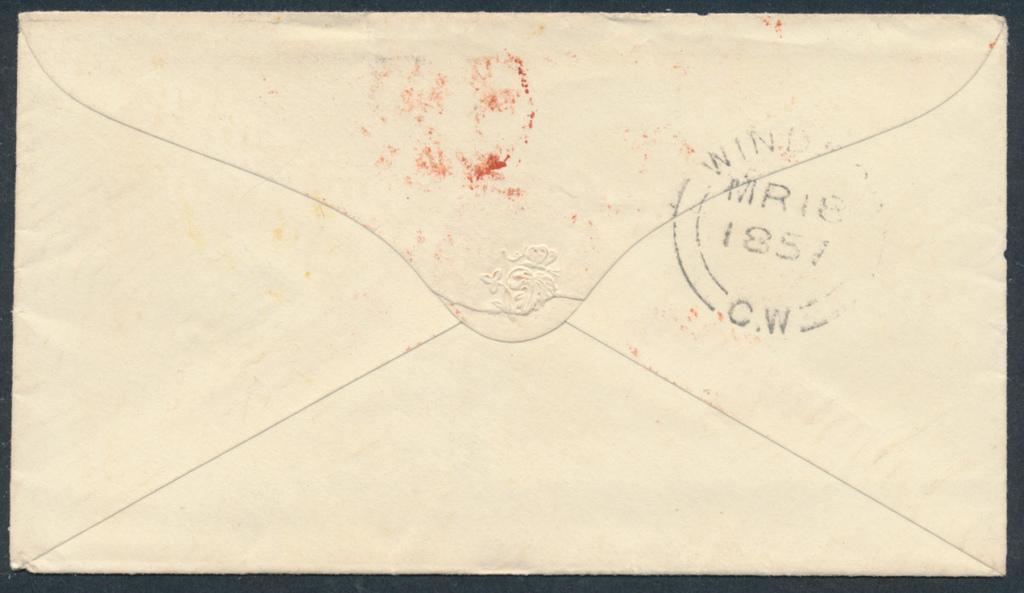<image>
Relay a brief, clear account of the picture shown. The back of a cream colored envelope has a stamp with the letters CW on it. 